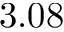<formula> <loc_0><loc_0><loc_500><loc_500>3 . 0 8</formula> 